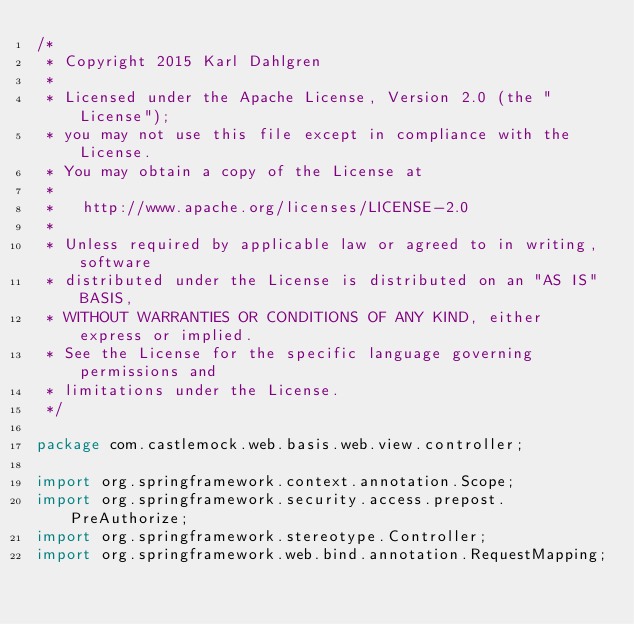Convert code to text. <code><loc_0><loc_0><loc_500><loc_500><_Java_>/*
 * Copyright 2015 Karl Dahlgren
 *
 * Licensed under the Apache License, Version 2.0 (the "License");
 * you may not use this file except in compliance with the License.
 * You may obtain a copy of the License at
 *
 *   http://www.apache.org/licenses/LICENSE-2.0
 *
 * Unless required by applicable law or agreed to in writing, software
 * distributed under the License is distributed on an "AS IS" BASIS,
 * WITHOUT WARRANTIES OR CONDITIONS OF ANY KIND, either express or implied.
 * See the License for the specific language governing permissions and
 * limitations under the License.
 */

package com.castlemock.web.basis.web.view.controller;

import org.springframework.context.annotation.Scope;
import org.springframework.security.access.prepost.PreAuthorize;
import org.springframework.stereotype.Controller;
import org.springframework.web.bind.annotation.RequestMapping;</code> 